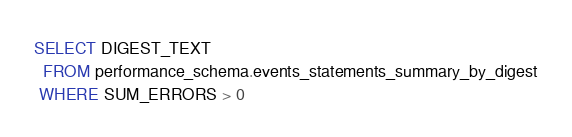Convert code to text. <code><loc_0><loc_0><loc_500><loc_500><_SQL_>SELECT DIGEST_TEXT
  FROM performance_schema.events_statements_summary_by_digest
 WHERE SUM_ERRORS > 0
</code> 